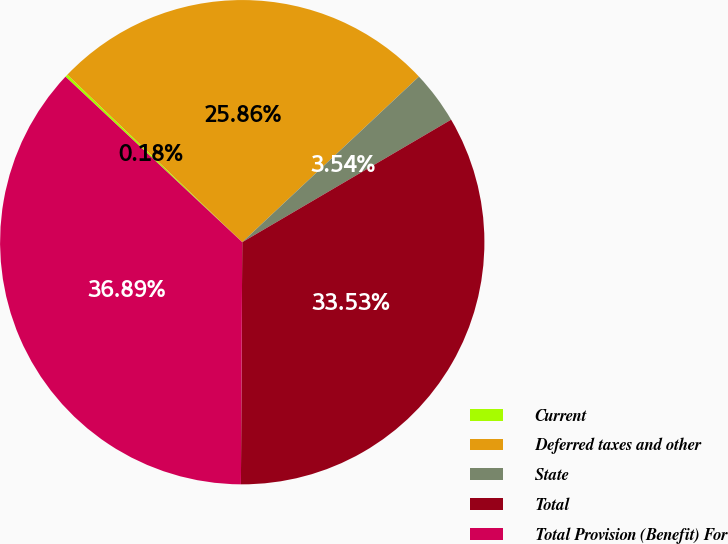Convert chart to OTSL. <chart><loc_0><loc_0><loc_500><loc_500><pie_chart><fcel>Current<fcel>Deferred taxes and other<fcel>State<fcel>Total<fcel>Total Provision (Benefit) For<nl><fcel>0.18%<fcel>25.86%<fcel>3.54%<fcel>33.53%<fcel>36.89%<nl></chart> 